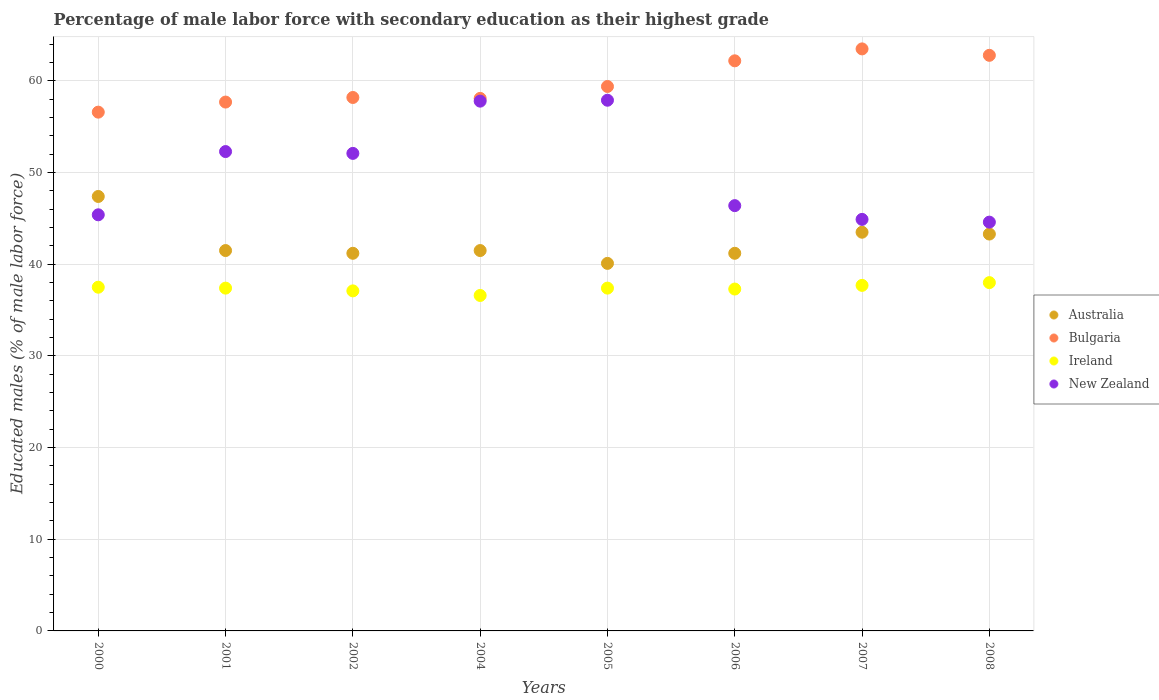Is the number of dotlines equal to the number of legend labels?
Your answer should be very brief. Yes. What is the percentage of male labor force with secondary education in New Zealand in 2006?
Your answer should be compact. 46.4. Across all years, what is the maximum percentage of male labor force with secondary education in New Zealand?
Offer a terse response. 57.9. Across all years, what is the minimum percentage of male labor force with secondary education in Bulgaria?
Offer a very short reply. 56.6. What is the total percentage of male labor force with secondary education in New Zealand in the graph?
Offer a very short reply. 401.4. What is the difference between the percentage of male labor force with secondary education in Ireland in 2002 and that in 2006?
Your response must be concise. -0.2. What is the average percentage of male labor force with secondary education in Australia per year?
Keep it short and to the point. 42.46. In the year 2007, what is the difference between the percentage of male labor force with secondary education in Bulgaria and percentage of male labor force with secondary education in New Zealand?
Make the answer very short. 18.6. In how many years, is the percentage of male labor force with secondary education in Ireland greater than 50 %?
Provide a short and direct response. 0. What is the ratio of the percentage of male labor force with secondary education in Australia in 2006 to that in 2007?
Offer a very short reply. 0.95. Is the percentage of male labor force with secondary education in Bulgaria in 2000 less than that in 2007?
Offer a terse response. Yes. What is the difference between the highest and the second highest percentage of male labor force with secondary education in New Zealand?
Provide a succinct answer. 0.1. What is the difference between the highest and the lowest percentage of male labor force with secondary education in Bulgaria?
Your answer should be very brief. 6.9. In how many years, is the percentage of male labor force with secondary education in New Zealand greater than the average percentage of male labor force with secondary education in New Zealand taken over all years?
Your answer should be very brief. 4. Does the percentage of male labor force with secondary education in Australia monotonically increase over the years?
Offer a terse response. No. Is the percentage of male labor force with secondary education in Ireland strictly less than the percentage of male labor force with secondary education in Bulgaria over the years?
Keep it short and to the point. Yes. How many dotlines are there?
Your response must be concise. 4. How many years are there in the graph?
Provide a succinct answer. 8. What is the difference between two consecutive major ticks on the Y-axis?
Provide a short and direct response. 10. Does the graph contain any zero values?
Your answer should be very brief. No. Where does the legend appear in the graph?
Give a very brief answer. Center right. How many legend labels are there?
Provide a short and direct response. 4. How are the legend labels stacked?
Provide a succinct answer. Vertical. What is the title of the graph?
Ensure brevity in your answer.  Percentage of male labor force with secondary education as their highest grade. Does "Angola" appear as one of the legend labels in the graph?
Your answer should be very brief. No. What is the label or title of the X-axis?
Provide a short and direct response. Years. What is the label or title of the Y-axis?
Offer a very short reply. Educated males (% of male labor force). What is the Educated males (% of male labor force) in Australia in 2000?
Offer a terse response. 47.4. What is the Educated males (% of male labor force) of Bulgaria in 2000?
Offer a very short reply. 56.6. What is the Educated males (% of male labor force) of Ireland in 2000?
Ensure brevity in your answer.  37.5. What is the Educated males (% of male labor force) in New Zealand in 2000?
Make the answer very short. 45.4. What is the Educated males (% of male labor force) in Australia in 2001?
Ensure brevity in your answer.  41.5. What is the Educated males (% of male labor force) in Bulgaria in 2001?
Your answer should be very brief. 57.7. What is the Educated males (% of male labor force) of Ireland in 2001?
Give a very brief answer. 37.4. What is the Educated males (% of male labor force) in New Zealand in 2001?
Ensure brevity in your answer.  52.3. What is the Educated males (% of male labor force) in Australia in 2002?
Make the answer very short. 41.2. What is the Educated males (% of male labor force) in Bulgaria in 2002?
Keep it short and to the point. 58.2. What is the Educated males (% of male labor force) in Ireland in 2002?
Your response must be concise. 37.1. What is the Educated males (% of male labor force) in New Zealand in 2002?
Ensure brevity in your answer.  52.1. What is the Educated males (% of male labor force) of Australia in 2004?
Your answer should be compact. 41.5. What is the Educated males (% of male labor force) in Bulgaria in 2004?
Offer a very short reply. 58.1. What is the Educated males (% of male labor force) in Ireland in 2004?
Provide a short and direct response. 36.6. What is the Educated males (% of male labor force) in New Zealand in 2004?
Your response must be concise. 57.8. What is the Educated males (% of male labor force) in Australia in 2005?
Provide a short and direct response. 40.1. What is the Educated males (% of male labor force) of Bulgaria in 2005?
Your answer should be very brief. 59.4. What is the Educated males (% of male labor force) of Ireland in 2005?
Ensure brevity in your answer.  37.4. What is the Educated males (% of male labor force) of New Zealand in 2005?
Your response must be concise. 57.9. What is the Educated males (% of male labor force) of Australia in 2006?
Your answer should be very brief. 41.2. What is the Educated males (% of male labor force) of Bulgaria in 2006?
Provide a short and direct response. 62.2. What is the Educated males (% of male labor force) of Ireland in 2006?
Make the answer very short. 37.3. What is the Educated males (% of male labor force) of New Zealand in 2006?
Provide a succinct answer. 46.4. What is the Educated males (% of male labor force) in Australia in 2007?
Your answer should be compact. 43.5. What is the Educated males (% of male labor force) of Bulgaria in 2007?
Your response must be concise. 63.5. What is the Educated males (% of male labor force) in Ireland in 2007?
Provide a succinct answer. 37.7. What is the Educated males (% of male labor force) of New Zealand in 2007?
Keep it short and to the point. 44.9. What is the Educated males (% of male labor force) in Australia in 2008?
Your response must be concise. 43.3. What is the Educated males (% of male labor force) in Bulgaria in 2008?
Give a very brief answer. 62.8. What is the Educated males (% of male labor force) in New Zealand in 2008?
Your response must be concise. 44.6. Across all years, what is the maximum Educated males (% of male labor force) in Australia?
Keep it short and to the point. 47.4. Across all years, what is the maximum Educated males (% of male labor force) in Bulgaria?
Offer a terse response. 63.5. Across all years, what is the maximum Educated males (% of male labor force) in New Zealand?
Make the answer very short. 57.9. Across all years, what is the minimum Educated males (% of male labor force) in Australia?
Make the answer very short. 40.1. Across all years, what is the minimum Educated males (% of male labor force) in Bulgaria?
Make the answer very short. 56.6. Across all years, what is the minimum Educated males (% of male labor force) of Ireland?
Your answer should be compact. 36.6. Across all years, what is the minimum Educated males (% of male labor force) of New Zealand?
Provide a short and direct response. 44.6. What is the total Educated males (% of male labor force) in Australia in the graph?
Provide a succinct answer. 339.7. What is the total Educated males (% of male labor force) in Bulgaria in the graph?
Give a very brief answer. 478.5. What is the total Educated males (% of male labor force) of Ireland in the graph?
Offer a very short reply. 299. What is the total Educated males (% of male labor force) of New Zealand in the graph?
Make the answer very short. 401.4. What is the difference between the Educated males (% of male labor force) of Ireland in 2000 and that in 2002?
Provide a short and direct response. 0.4. What is the difference between the Educated males (% of male labor force) in Australia in 2000 and that in 2004?
Provide a short and direct response. 5.9. What is the difference between the Educated males (% of male labor force) of Bulgaria in 2000 and that in 2004?
Keep it short and to the point. -1.5. What is the difference between the Educated males (% of male labor force) in Ireland in 2000 and that in 2004?
Your response must be concise. 0.9. What is the difference between the Educated males (% of male labor force) of New Zealand in 2000 and that in 2004?
Your answer should be compact. -12.4. What is the difference between the Educated males (% of male labor force) of Australia in 2000 and that in 2005?
Offer a terse response. 7.3. What is the difference between the Educated males (% of male labor force) in Ireland in 2000 and that in 2005?
Keep it short and to the point. 0.1. What is the difference between the Educated males (% of male labor force) of New Zealand in 2000 and that in 2005?
Offer a very short reply. -12.5. What is the difference between the Educated males (% of male labor force) of Australia in 2000 and that in 2006?
Provide a short and direct response. 6.2. What is the difference between the Educated males (% of male labor force) of Bulgaria in 2000 and that in 2006?
Your answer should be very brief. -5.6. What is the difference between the Educated males (% of male labor force) of New Zealand in 2000 and that in 2006?
Your response must be concise. -1. What is the difference between the Educated males (% of male labor force) in Australia in 2000 and that in 2008?
Offer a very short reply. 4.1. What is the difference between the Educated males (% of male labor force) in Bulgaria in 2000 and that in 2008?
Provide a succinct answer. -6.2. What is the difference between the Educated males (% of male labor force) of New Zealand in 2000 and that in 2008?
Give a very brief answer. 0.8. What is the difference between the Educated males (% of male labor force) in Bulgaria in 2001 and that in 2002?
Offer a very short reply. -0.5. What is the difference between the Educated males (% of male labor force) in Australia in 2001 and that in 2004?
Ensure brevity in your answer.  0. What is the difference between the Educated males (% of male labor force) in Australia in 2001 and that in 2005?
Keep it short and to the point. 1.4. What is the difference between the Educated males (% of male labor force) of Bulgaria in 2001 and that in 2005?
Your answer should be compact. -1.7. What is the difference between the Educated males (% of male labor force) of Ireland in 2001 and that in 2005?
Offer a very short reply. 0. What is the difference between the Educated males (% of male labor force) in New Zealand in 2001 and that in 2005?
Offer a very short reply. -5.6. What is the difference between the Educated males (% of male labor force) in Australia in 2001 and that in 2006?
Keep it short and to the point. 0.3. What is the difference between the Educated males (% of male labor force) in Bulgaria in 2001 and that in 2006?
Provide a short and direct response. -4.5. What is the difference between the Educated males (% of male labor force) of Ireland in 2001 and that in 2008?
Your answer should be compact. -0.6. What is the difference between the Educated males (% of male labor force) in Ireland in 2002 and that in 2004?
Make the answer very short. 0.5. What is the difference between the Educated males (% of male labor force) in Australia in 2002 and that in 2005?
Your answer should be compact. 1.1. What is the difference between the Educated males (% of male labor force) in Ireland in 2002 and that in 2005?
Keep it short and to the point. -0.3. What is the difference between the Educated males (% of male labor force) in New Zealand in 2002 and that in 2005?
Offer a very short reply. -5.8. What is the difference between the Educated males (% of male labor force) in Australia in 2002 and that in 2006?
Make the answer very short. 0. What is the difference between the Educated males (% of male labor force) in Bulgaria in 2002 and that in 2006?
Offer a very short reply. -4. What is the difference between the Educated males (% of male labor force) in Australia in 2002 and that in 2007?
Make the answer very short. -2.3. What is the difference between the Educated males (% of male labor force) of Bulgaria in 2002 and that in 2007?
Your answer should be compact. -5.3. What is the difference between the Educated males (% of male labor force) in Ireland in 2002 and that in 2007?
Your answer should be very brief. -0.6. What is the difference between the Educated males (% of male labor force) of New Zealand in 2002 and that in 2007?
Your answer should be very brief. 7.2. What is the difference between the Educated males (% of male labor force) of Australia in 2002 and that in 2008?
Make the answer very short. -2.1. What is the difference between the Educated males (% of male labor force) of Ireland in 2002 and that in 2008?
Offer a very short reply. -0.9. What is the difference between the Educated males (% of male labor force) of Australia in 2004 and that in 2005?
Make the answer very short. 1.4. What is the difference between the Educated males (% of male labor force) of Bulgaria in 2004 and that in 2005?
Provide a succinct answer. -1.3. What is the difference between the Educated males (% of male labor force) in Ireland in 2004 and that in 2005?
Ensure brevity in your answer.  -0.8. What is the difference between the Educated males (% of male labor force) in Bulgaria in 2004 and that in 2006?
Offer a very short reply. -4.1. What is the difference between the Educated males (% of male labor force) in New Zealand in 2004 and that in 2006?
Offer a terse response. 11.4. What is the difference between the Educated males (% of male labor force) in Ireland in 2004 and that in 2007?
Offer a very short reply. -1.1. What is the difference between the Educated males (% of male labor force) of New Zealand in 2004 and that in 2007?
Offer a very short reply. 12.9. What is the difference between the Educated males (% of male labor force) in Bulgaria in 2004 and that in 2008?
Ensure brevity in your answer.  -4.7. What is the difference between the Educated males (% of male labor force) of New Zealand in 2004 and that in 2008?
Give a very brief answer. 13.2. What is the difference between the Educated males (% of male labor force) of Ireland in 2005 and that in 2006?
Give a very brief answer. 0.1. What is the difference between the Educated males (% of male labor force) in New Zealand in 2005 and that in 2007?
Provide a succinct answer. 13. What is the difference between the Educated males (% of male labor force) of New Zealand in 2005 and that in 2008?
Provide a short and direct response. 13.3. What is the difference between the Educated males (% of male labor force) of Ireland in 2006 and that in 2007?
Ensure brevity in your answer.  -0.4. What is the difference between the Educated males (% of male labor force) in New Zealand in 2006 and that in 2007?
Provide a short and direct response. 1.5. What is the difference between the Educated males (% of male labor force) in Australia in 2007 and that in 2008?
Give a very brief answer. 0.2. What is the difference between the Educated males (% of male labor force) in Bulgaria in 2007 and that in 2008?
Offer a very short reply. 0.7. What is the difference between the Educated males (% of male labor force) of Ireland in 2007 and that in 2008?
Ensure brevity in your answer.  -0.3. What is the difference between the Educated males (% of male labor force) of New Zealand in 2007 and that in 2008?
Provide a succinct answer. 0.3. What is the difference between the Educated males (% of male labor force) of Bulgaria in 2000 and the Educated males (% of male labor force) of Ireland in 2001?
Your answer should be very brief. 19.2. What is the difference between the Educated males (% of male labor force) of Ireland in 2000 and the Educated males (% of male labor force) of New Zealand in 2001?
Your answer should be compact. -14.8. What is the difference between the Educated males (% of male labor force) of Australia in 2000 and the Educated males (% of male labor force) of Bulgaria in 2002?
Ensure brevity in your answer.  -10.8. What is the difference between the Educated males (% of male labor force) in Bulgaria in 2000 and the Educated males (% of male labor force) in Ireland in 2002?
Your response must be concise. 19.5. What is the difference between the Educated males (% of male labor force) in Bulgaria in 2000 and the Educated males (% of male labor force) in New Zealand in 2002?
Your answer should be compact. 4.5. What is the difference between the Educated males (% of male labor force) of Ireland in 2000 and the Educated males (% of male labor force) of New Zealand in 2002?
Offer a terse response. -14.6. What is the difference between the Educated males (% of male labor force) in Australia in 2000 and the Educated males (% of male labor force) in Ireland in 2004?
Make the answer very short. 10.8. What is the difference between the Educated males (% of male labor force) in Australia in 2000 and the Educated males (% of male labor force) in New Zealand in 2004?
Your answer should be very brief. -10.4. What is the difference between the Educated males (% of male labor force) of Bulgaria in 2000 and the Educated males (% of male labor force) of New Zealand in 2004?
Provide a short and direct response. -1.2. What is the difference between the Educated males (% of male labor force) in Ireland in 2000 and the Educated males (% of male labor force) in New Zealand in 2004?
Give a very brief answer. -20.3. What is the difference between the Educated males (% of male labor force) of Australia in 2000 and the Educated males (% of male labor force) of Bulgaria in 2005?
Your response must be concise. -12. What is the difference between the Educated males (% of male labor force) in Bulgaria in 2000 and the Educated males (% of male labor force) in Ireland in 2005?
Your answer should be compact. 19.2. What is the difference between the Educated males (% of male labor force) of Bulgaria in 2000 and the Educated males (% of male labor force) of New Zealand in 2005?
Keep it short and to the point. -1.3. What is the difference between the Educated males (% of male labor force) in Ireland in 2000 and the Educated males (% of male labor force) in New Zealand in 2005?
Ensure brevity in your answer.  -20.4. What is the difference between the Educated males (% of male labor force) in Australia in 2000 and the Educated males (% of male labor force) in Bulgaria in 2006?
Your answer should be compact. -14.8. What is the difference between the Educated males (% of male labor force) of Australia in 2000 and the Educated males (% of male labor force) of Ireland in 2006?
Your response must be concise. 10.1. What is the difference between the Educated males (% of male labor force) of Bulgaria in 2000 and the Educated males (% of male labor force) of Ireland in 2006?
Offer a terse response. 19.3. What is the difference between the Educated males (% of male labor force) in Australia in 2000 and the Educated males (% of male labor force) in Bulgaria in 2007?
Offer a terse response. -16.1. What is the difference between the Educated males (% of male labor force) of Australia in 2000 and the Educated males (% of male labor force) of Ireland in 2007?
Provide a succinct answer. 9.7. What is the difference between the Educated males (% of male labor force) of Australia in 2000 and the Educated males (% of male labor force) of New Zealand in 2007?
Your answer should be compact. 2.5. What is the difference between the Educated males (% of male labor force) of Bulgaria in 2000 and the Educated males (% of male labor force) of Ireland in 2007?
Your answer should be compact. 18.9. What is the difference between the Educated males (% of male labor force) in Ireland in 2000 and the Educated males (% of male labor force) in New Zealand in 2007?
Offer a terse response. -7.4. What is the difference between the Educated males (% of male labor force) in Australia in 2000 and the Educated males (% of male labor force) in Bulgaria in 2008?
Offer a very short reply. -15.4. What is the difference between the Educated males (% of male labor force) in Australia in 2000 and the Educated males (% of male labor force) in Ireland in 2008?
Your answer should be compact. 9.4. What is the difference between the Educated males (% of male labor force) in Australia in 2000 and the Educated males (% of male labor force) in New Zealand in 2008?
Provide a short and direct response. 2.8. What is the difference between the Educated males (% of male labor force) in Bulgaria in 2000 and the Educated males (% of male labor force) in New Zealand in 2008?
Ensure brevity in your answer.  12. What is the difference between the Educated males (% of male labor force) in Ireland in 2000 and the Educated males (% of male labor force) in New Zealand in 2008?
Make the answer very short. -7.1. What is the difference between the Educated males (% of male labor force) in Australia in 2001 and the Educated males (% of male labor force) in Bulgaria in 2002?
Provide a short and direct response. -16.7. What is the difference between the Educated males (% of male labor force) in Australia in 2001 and the Educated males (% of male labor force) in Ireland in 2002?
Offer a very short reply. 4.4. What is the difference between the Educated males (% of male labor force) of Australia in 2001 and the Educated males (% of male labor force) of New Zealand in 2002?
Your answer should be compact. -10.6. What is the difference between the Educated males (% of male labor force) of Bulgaria in 2001 and the Educated males (% of male labor force) of Ireland in 2002?
Provide a short and direct response. 20.6. What is the difference between the Educated males (% of male labor force) in Bulgaria in 2001 and the Educated males (% of male labor force) in New Zealand in 2002?
Your answer should be compact. 5.6. What is the difference between the Educated males (% of male labor force) in Ireland in 2001 and the Educated males (% of male labor force) in New Zealand in 2002?
Your answer should be very brief. -14.7. What is the difference between the Educated males (% of male labor force) in Australia in 2001 and the Educated males (% of male labor force) in Bulgaria in 2004?
Provide a short and direct response. -16.6. What is the difference between the Educated males (% of male labor force) of Australia in 2001 and the Educated males (% of male labor force) of Ireland in 2004?
Ensure brevity in your answer.  4.9. What is the difference between the Educated males (% of male labor force) in Australia in 2001 and the Educated males (% of male labor force) in New Zealand in 2004?
Give a very brief answer. -16.3. What is the difference between the Educated males (% of male labor force) in Bulgaria in 2001 and the Educated males (% of male labor force) in Ireland in 2004?
Provide a short and direct response. 21.1. What is the difference between the Educated males (% of male labor force) in Ireland in 2001 and the Educated males (% of male labor force) in New Zealand in 2004?
Provide a succinct answer. -20.4. What is the difference between the Educated males (% of male labor force) in Australia in 2001 and the Educated males (% of male labor force) in Bulgaria in 2005?
Your answer should be very brief. -17.9. What is the difference between the Educated males (% of male labor force) of Australia in 2001 and the Educated males (% of male labor force) of Ireland in 2005?
Your response must be concise. 4.1. What is the difference between the Educated males (% of male labor force) in Australia in 2001 and the Educated males (% of male labor force) in New Zealand in 2005?
Your response must be concise. -16.4. What is the difference between the Educated males (% of male labor force) of Bulgaria in 2001 and the Educated males (% of male labor force) of Ireland in 2005?
Provide a succinct answer. 20.3. What is the difference between the Educated males (% of male labor force) in Ireland in 2001 and the Educated males (% of male labor force) in New Zealand in 2005?
Your answer should be compact. -20.5. What is the difference between the Educated males (% of male labor force) in Australia in 2001 and the Educated males (% of male labor force) in Bulgaria in 2006?
Provide a succinct answer. -20.7. What is the difference between the Educated males (% of male labor force) of Australia in 2001 and the Educated males (% of male labor force) of New Zealand in 2006?
Offer a very short reply. -4.9. What is the difference between the Educated males (% of male labor force) in Bulgaria in 2001 and the Educated males (% of male labor force) in Ireland in 2006?
Keep it short and to the point. 20.4. What is the difference between the Educated males (% of male labor force) of Ireland in 2001 and the Educated males (% of male labor force) of New Zealand in 2006?
Your answer should be compact. -9. What is the difference between the Educated males (% of male labor force) in Australia in 2001 and the Educated males (% of male labor force) in Bulgaria in 2007?
Keep it short and to the point. -22. What is the difference between the Educated males (% of male labor force) in Australia in 2001 and the Educated males (% of male labor force) in New Zealand in 2007?
Offer a very short reply. -3.4. What is the difference between the Educated males (% of male labor force) in Bulgaria in 2001 and the Educated males (% of male labor force) in New Zealand in 2007?
Give a very brief answer. 12.8. What is the difference between the Educated males (% of male labor force) of Ireland in 2001 and the Educated males (% of male labor force) of New Zealand in 2007?
Provide a short and direct response. -7.5. What is the difference between the Educated males (% of male labor force) of Australia in 2001 and the Educated males (% of male labor force) of Bulgaria in 2008?
Your answer should be compact. -21.3. What is the difference between the Educated males (% of male labor force) of Australia in 2001 and the Educated males (% of male labor force) of Ireland in 2008?
Give a very brief answer. 3.5. What is the difference between the Educated males (% of male labor force) in Bulgaria in 2001 and the Educated males (% of male labor force) in New Zealand in 2008?
Offer a terse response. 13.1. What is the difference between the Educated males (% of male labor force) of Australia in 2002 and the Educated males (% of male labor force) of Bulgaria in 2004?
Make the answer very short. -16.9. What is the difference between the Educated males (% of male labor force) of Australia in 2002 and the Educated males (% of male labor force) of New Zealand in 2004?
Provide a succinct answer. -16.6. What is the difference between the Educated males (% of male labor force) in Bulgaria in 2002 and the Educated males (% of male labor force) in Ireland in 2004?
Provide a succinct answer. 21.6. What is the difference between the Educated males (% of male labor force) of Ireland in 2002 and the Educated males (% of male labor force) of New Zealand in 2004?
Provide a short and direct response. -20.7. What is the difference between the Educated males (% of male labor force) of Australia in 2002 and the Educated males (% of male labor force) of Bulgaria in 2005?
Make the answer very short. -18.2. What is the difference between the Educated males (% of male labor force) of Australia in 2002 and the Educated males (% of male labor force) of New Zealand in 2005?
Offer a very short reply. -16.7. What is the difference between the Educated males (% of male labor force) in Bulgaria in 2002 and the Educated males (% of male labor force) in Ireland in 2005?
Offer a terse response. 20.8. What is the difference between the Educated males (% of male labor force) of Bulgaria in 2002 and the Educated males (% of male labor force) of New Zealand in 2005?
Give a very brief answer. 0.3. What is the difference between the Educated males (% of male labor force) of Ireland in 2002 and the Educated males (% of male labor force) of New Zealand in 2005?
Offer a very short reply. -20.8. What is the difference between the Educated males (% of male labor force) of Australia in 2002 and the Educated males (% of male labor force) of Bulgaria in 2006?
Your response must be concise. -21. What is the difference between the Educated males (% of male labor force) in Bulgaria in 2002 and the Educated males (% of male labor force) in Ireland in 2006?
Offer a very short reply. 20.9. What is the difference between the Educated males (% of male labor force) of Ireland in 2002 and the Educated males (% of male labor force) of New Zealand in 2006?
Keep it short and to the point. -9.3. What is the difference between the Educated males (% of male labor force) in Australia in 2002 and the Educated males (% of male labor force) in Bulgaria in 2007?
Make the answer very short. -22.3. What is the difference between the Educated males (% of male labor force) of Australia in 2002 and the Educated males (% of male labor force) of Bulgaria in 2008?
Give a very brief answer. -21.6. What is the difference between the Educated males (% of male labor force) of Australia in 2002 and the Educated males (% of male labor force) of Ireland in 2008?
Provide a short and direct response. 3.2. What is the difference between the Educated males (% of male labor force) of Bulgaria in 2002 and the Educated males (% of male labor force) of Ireland in 2008?
Your answer should be compact. 20.2. What is the difference between the Educated males (% of male labor force) of Bulgaria in 2002 and the Educated males (% of male labor force) of New Zealand in 2008?
Offer a very short reply. 13.6. What is the difference between the Educated males (% of male labor force) of Australia in 2004 and the Educated males (% of male labor force) of Bulgaria in 2005?
Your answer should be compact. -17.9. What is the difference between the Educated males (% of male labor force) in Australia in 2004 and the Educated males (% of male labor force) in New Zealand in 2005?
Your response must be concise. -16.4. What is the difference between the Educated males (% of male labor force) of Bulgaria in 2004 and the Educated males (% of male labor force) of Ireland in 2005?
Keep it short and to the point. 20.7. What is the difference between the Educated males (% of male labor force) of Ireland in 2004 and the Educated males (% of male labor force) of New Zealand in 2005?
Offer a terse response. -21.3. What is the difference between the Educated males (% of male labor force) of Australia in 2004 and the Educated males (% of male labor force) of Bulgaria in 2006?
Your response must be concise. -20.7. What is the difference between the Educated males (% of male labor force) of Australia in 2004 and the Educated males (% of male labor force) of New Zealand in 2006?
Your answer should be very brief. -4.9. What is the difference between the Educated males (% of male labor force) in Bulgaria in 2004 and the Educated males (% of male labor force) in Ireland in 2006?
Your answer should be compact. 20.8. What is the difference between the Educated males (% of male labor force) of Ireland in 2004 and the Educated males (% of male labor force) of New Zealand in 2006?
Ensure brevity in your answer.  -9.8. What is the difference between the Educated males (% of male labor force) in Australia in 2004 and the Educated males (% of male labor force) in Bulgaria in 2007?
Provide a short and direct response. -22. What is the difference between the Educated males (% of male labor force) of Australia in 2004 and the Educated males (% of male labor force) of Ireland in 2007?
Make the answer very short. 3.8. What is the difference between the Educated males (% of male labor force) in Australia in 2004 and the Educated males (% of male labor force) in New Zealand in 2007?
Your answer should be compact. -3.4. What is the difference between the Educated males (% of male labor force) of Bulgaria in 2004 and the Educated males (% of male labor force) of Ireland in 2007?
Provide a succinct answer. 20.4. What is the difference between the Educated males (% of male labor force) of Ireland in 2004 and the Educated males (% of male labor force) of New Zealand in 2007?
Give a very brief answer. -8.3. What is the difference between the Educated males (% of male labor force) in Australia in 2004 and the Educated males (% of male labor force) in Bulgaria in 2008?
Your answer should be very brief. -21.3. What is the difference between the Educated males (% of male labor force) in Bulgaria in 2004 and the Educated males (% of male labor force) in Ireland in 2008?
Keep it short and to the point. 20.1. What is the difference between the Educated males (% of male labor force) of Australia in 2005 and the Educated males (% of male labor force) of Bulgaria in 2006?
Make the answer very short. -22.1. What is the difference between the Educated males (% of male labor force) in Australia in 2005 and the Educated males (% of male labor force) in Ireland in 2006?
Make the answer very short. 2.8. What is the difference between the Educated males (% of male labor force) in Australia in 2005 and the Educated males (% of male labor force) in New Zealand in 2006?
Your answer should be compact. -6.3. What is the difference between the Educated males (% of male labor force) of Bulgaria in 2005 and the Educated males (% of male labor force) of Ireland in 2006?
Your response must be concise. 22.1. What is the difference between the Educated males (% of male labor force) of Australia in 2005 and the Educated males (% of male labor force) of Bulgaria in 2007?
Offer a very short reply. -23.4. What is the difference between the Educated males (% of male labor force) in Australia in 2005 and the Educated males (% of male labor force) in Ireland in 2007?
Offer a very short reply. 2.4. What is the difference between the Educated males (% of male labor force) of Australia in 2005 and the Educated males (% of male labor force) of New Zealand in 2007?
Your response must be concise. -4.8. What is the difference between the Educated males (% of male labor force) of Bulgaria in 2005 and the Educated males (% of male labor force) of Ireland in 2007?
Ensure brevity in your answer.  21.7. What is the difference between the Educated males (% of male labor force) in Bulgaria in 2005 and the Educated males (% of male labor force) in New Zealand in 2007?
Your answer should be very brief. 14.5. What is the difference between the Educated males (% of male labor force) of Australia in 2005 and the Educated males (% of male labor force) of Bulgaria in 2008?
Provide a short and direct response. -22.7. What is the difference between the Educated males (% of male labor force) in Bulgaria in 2005 and the Educated males (% of male labor force) in Ireland in 2008?
Give a very brief answer. 21.4. What is the difference between the Educated males (% of male labor force) in Ireland in 2005 and the Educated males (% of male labor force) in New Zealand in 2008?
Your answer should be very brief. -7.2. What is the difference between the Educated males (% of male labor force) of Australia in 2006 and the Educated males (% of male labor force) of Bulgaria in 2007?
Your response must be concise. -22.3. What is the difference between the Educated males (% of male labor force) of Australia in 2006 and the Educated males (% of male labor force) of Ireland in 2007?
Your answer should be compact. 3.5. What is the difference between the Educated males (% of male labor force) of Australia in 2006 and the Educated males (% of male labor force) of New Zealand in 2007?
Your response must be concise. -3.7. What is the difference between the Educated males (% of male labor force) in Bulgaria in 2006 and the Educated males (% of male labor force) in Ireland in 2007?
Keep it short and to the point. 24.5. What is the difference between the Educated males (% of male labor force) in Bulgaria in 2006 and the Educated males (% of male labor force) in New Zealand in 2007?
Your answer should be compact. 17.3. What is the difference between the Educated males (% of male labor force) of Australia in 2006 and the Educated males (% of male labor force) of Bulgaria in 2008?
Ensure brevity in your answer.  -21.6. What is the difference between the Educated males (% of male labor force) in Australia in 2006 and the Educated males (% of male labor force) in Ireland in 2008?
Keep it short and to the point. 3.2. What is the difference between the Educated males (% of male labor force) of Australia in 2006 and the Educated males (% of male labor force) of New Zealand in 2008?
Provide a short and direct response. -3.4. What is the difference between the Educated males (% of male labor force) in Bulgaria in 2006 and the Educated males (% of male labor force) in Ireland in 2008?
Keep it short and to the point. 24.2. What is the difference between the Educated males (% of male labor force) in Australia in 2007 and the Educated males (% of male labor force) in Bulgaria in 2008?
Provide a short and direct response. -19.3. What is the difference between the Educated males (% of male labor force) of Australia in 2007 and the Educated males (% of male labor force) of Ireland in 2008?
Provide a succinct answer. 5.5. What is the difference between the Educated males (% of male labor force) of Bulgaria in 2007 and the Educated males (% of male labor force) of Ireland in 2008?
Provide a succinct answer. 25.5. What is the difference between the Educated males (% of male labor force) in Bulgaria in 2007 and the Educated males (% of male labor force) in New Zealand in 2008?
Your response must be concise. 18.9. What is the difference between the Educated males (% of male labor force) of Ireland in 2007 and the Educated males (% of male labor force) of New Zealand in 2008?
Ensure brevity in your answer.  -6.9. What is the average Educated males (% of male labor force) in Australia per year?
Provide a short and direct response. 42.46. What is the average Educated males (% of male labor force) of Bulgaria per year?
Keep it short and to the point. 59.81. What is the average Educated males (% of male labor force) in Ireland per year?
Keep it short and to the point. 37.38. What is the average Educated males (% of male labor force) in New Zealand per year?
Offer a terse response. 50.17. In the year 2000, what is the difference between the Educated males (% of male labor force) in Australia and Educated males (% of male labor force) in Bulgaria?
Keep it short and to the point. -9.2. In the year 2000, what is the difference between the Educated males (% of male labor force) in Australia and Educated males (% of male labor force) in Ireland?
Your response must be concise. 9.9. In the year 2000, what is the difference between the Educated males (% of male labor force) in Australia and Educated males (% of male labor force) in New Zealand?
Offer a terse response. 2. In the year 2000, what is the difference between the Educated males (% of male labor force) of Bulgaria and Educated males (% of male labor force) of Ireland?
Your response must be concise. 19.1. In the year 2000, what is the difference between the Educated males (% of male labor force) of Bulgaria and Educated males (% of male labor force) of New Zealand?
Offer a terse response. 11.2. In the year 2001, what is the difference between the Educated males (% of male labor force) in Australia and Educated males (% of male labor force) in Bulgaria?
Your response must be concise. -16.2. In the year 2001, what is the difference between the Educated males (% of male labor force) of Bulgaria and Educated males (% of male labor force) of Ireland?
Give a very brief answer. 20.3. In the year 2001, what is the difference between the Educated males (% of male labor force) in Bulgaria and Educated males (% of male labor force) in New Zealand?
Provide a short and direct response. 5.4. In the year 2001, what is the difference between the Educated males (% of male labor force) in Ireland and Educated males (% of male labor force) in New Zealand?
Offer a very short reply. -14.9. In the year 2002, what is the difference between the Educated males (% of male labor force) of Australia and Educated males (% of male labor force) of Ireland?
Ensure brevity in your answer.  4.1. In the year 2002, what is the difference between the Educated males (% of male labor force) in Bulgaria and Educated males (% of male labor force) in Ireland?
Provide a short and direct response. 21.1. In the year 2002, what is the difference between the Educated males (% of male labor force) of Bulgaria and Educated males (% of male labor force) of New Zealand?
Ensure brevity in your answer.  6.1. In the year 2002, what is the difference between the Educated males (% of male labor force) in Ireland and Educated males (% of male labor force) in New Zealand?
Offer a very short reply. -15. In the year 2004, what is the difference between the Educated males (% of male labor force) of Australia and Educated males (% of male labor force) of Bulgaria?
Provide a succinct answer. -16.6. In the year 2004, what is the difference between the Educated males (% of male labor force) of Australia and Educated males (% of male labor force) of Ireland?
Provide a short and direct response. 4.9. In the year 2004, what is the difference between the Educated males (% of male labor force) of Australia and Educated males (% of male labor force) of New Zealand?
Your answer should be very brief. -16.3. In the year 2004, what is the difference between the Educated males (% of male labor force) in Bulgaria and Educated males (% of male labor force) in Ireland?
Keep it short and to the point. 21.5. In the year 2004, what is the difference between the Educated males (% of male labor force) of Ireland and Educated males (% of male labor force) of New Zealand?
Make the answer very short. -21.2. In the year 2005, what is the difference between the Educated males (% of male labor force) of Australia and Educated males (% of male labor force) of Bulgaria?
Offer a very short reply. -19.3. In the year 2005, what is the difference between the Educated males (% of male labor force) of Australia and Educated males (% of male labor force) of Ireland?
Provide a succinct answer. 2.7. In the year 2005, what is the difference between the Educated males (% of male labor force) in Australia and Educated males (% of male labor force) in New Zealand?
Your response must be concise. -17.8. In the year 2005, what is the difference between the Educated males (% of male labor force) of Ireland and Educated males (% of male labor force) of New Zealand?
Your response must be concise. -20.5. In the year 2006, what is the difference between the Educated males (% of male labor force) in Bulgaria and Educated males (% of male labor force) in Ireland?
Your answer should be very brief. 24.9. In the year 2006, what is the difference between the Educated males (% of male labor force) in Bulgaria and Educated males (% of male labor force) in New Zealand?
Your answer should be very brief. 15.8. In the year 2006, what is the difference between the Educated males (% of male labor force) of Ireland and Educated males (% of male labor force) of New Zealand?
Offer a very short reply. -9.1. In the year 2007, what is the difference between the Educated males (% of male labor force) of Australia and Educated males (% of male labor force) of Ireland?
Make the answer very short. 5.8. In the year 2007, what is the difference between the Educated males (% of male labor force) in Australia and Educated males (% of male labor force) in New Zealand?
Your answer should be compact. -1.4. In the year 2007, what is the difference between the Educated males (% of male labor force) of Bulgaria and Educated males (% of male labor force) of Ireland?
Give a very brief answer. 25.8. In the year 2007, what is the difference between the Educated males (% of male labor force) of Bulgaria and Educated males (% of male labor force) of New Zealand?
Ensure brevity in your answer.  18.6. In the year 2007, what is the difference between the Educated males (% of male labor force) of Ireland and Educated males (% of male labor force) of New Zealand?
Offer a very short reply. -7.2. In the year 2008, what is the difference between the Educated males (% of male labor force) of Australia and Educated males (% of male labor force) of Bulgaria?
Keep it short and to the point. -19.5. In the year 2008, what is the difference between the Educated males (% of male labor force) in Australia and Educated males (% of male labor force) in Ireland?
Your answer should be compact. 5.3. In the year 2008, what is the difference between the Educated males (% of male labor force) in Australia and Educated males (% of male labor force) in New Zealand?
Make the answer very short. -1.3. In the year 2008, what is the difference between the Educated males (% of male labor force) of Bulgaria and Educated males (% of male labor force) of Ireland?
Your answer should be compact. 24.8. In the year 2008, what is the difference between the Educated males (% of male labor force) in Bulgaria and Educated males (% of male labor force) in New Zealand?
Ensure brevity in your answer.  18.2. In the year 2008, what is the difference between the Educated males (% of male labor force) in Ireland and Educated males (% of male labor force) in New Zealand?
Your answer should be compact. -6.6. What is the ratio of the Educated males (% of male labor force) of Australia in 2000 to that in 2001?
Offer a very short reply. 1.14. What is the ratio of the Educated males (% of male labor force) of Bulgaria in 2000 to that in 2001?
Make the answer very short. 0.98. What is the ratio of the Educated males (% of male labor force) of Ireland in 2000 to that in 2001?
Ensure brevity in your answer.  1. What is the ratio of the Educated males (% of male labor force) of New Zealand in 2000 to that in 2001?
Give a very brief answer. 0.87. What is the ratio of the Educated males (% of male labor force) of Australia in 2000 to that in 2002?
Give a very brief answer. 1.15. What is the ratio of the Educated males (% of male labor force) in Bulgaria in 2000 to that in 2002?
Offer a terse response. 0.97. What is the ratio of the Educated males (% of male labor force) of Ireland in 2000 to that in 2002?
Provide a succinct answer. 1.01. What is the ratio of the Educated males (% of male labor force) in New Zealand in 2000 to that in 2002?
Your response must be concise. 0.87. What is the ratio of the Educated males (% of male labor force) in Australia in 2000 to that in 2004?
Ensure brevity in your answer.  1.14. What is the ratio of the Educated males (% of male labor force) of Bulgaria in 2000 to that in 2004?
Provide a succinct answer. 0.97. What is the ratio of the Educated males (% of male labor force) in Ireland in 2000 to that in 2004?
Make the answer very short. 1.02. What is the ratio of the Educated males (% of male labor force) in New Zealand in 2000 to that in 2004?
Your response must be concise. 0.79. What is the ratio of the Educated males (% of male labor force) of Australia in 2000 to that in 2005?
Offer a terse response. 1.18. What is the ratio of the Educated males (% of male labor force) in Bulgaria in 2000 to that in 2005?
Keep it short and to the point. 0.95. What is the ratio of the Educated males (% of male labor force) of New Zealand in 2000 to that in 2005?
Make the answer very short. 0.78. What is the ratio of the Educated males (% of male labor force) of Australia in 2000 to that in 2006?
Keep it short and to the point. 1.15. What is the ratio of the Educated males (% of male labor force) of Bulgaria in 2000 to that in 2006?
Your answer should be very brief. 0.91. What is the ratio of the Educated males (% of male labor force) of Ireland in 2000 to that in 2006?
Give a very brief answer. 1.01. What is the ratio of the Educated males (% of male labor force) of New Zealand in 2000 to that in 2006?
Provide a succinct answer. 0.98. What is the ratio of the Educated males (% of male labor force) in Australia in 2000 to that in 2007?
Ensure brevity in your answer.  1.09. What is the ratio of the Educated males (% of male labor force) of Bulgaria in 2000 to that in 2007?
Your answer should be very brief. 0.89. What is the ratio of the Educated males (% of male labor force) of Ireland in 2000 to that in 2007?
Your answer should be compact. 0.99. What is the ratio of the Educated males (% of male labor force) of New Zealand in 2000 to that in 2007?
Provide a succinct answer. 1.01. What is the ratio of the Educated males (% of male labor force) of Australia in 2000 to that in 2008?
Give a very brief answer. 1.09. What is the ratio of the Educated males (% of male labor force) in Bulgaria in 2000 to that in 2008?
Your answer should be very brief. 0.9. What is the ratio of the Educated males (% of male labor force) of Ireland in 2000 to that in 2008?
Ensure brevity in your answer.  0.99. What is the ratio of the Educated males (% of male labor force) of New Zealand in 2000 to that in 2008?
Offer a very short reply. 1.02. What is the ratio of the Educated males (% of male labor force) of Australia in 2001 to that in 2002?
Your answer should be compact. 1.01. What is the ratio of the Educated males (% of male labor force) in Bulgaria in 2001 to that in 2002?
Keep it short and to the point. 0.99. What is the ratio of the Educated males (% of male labor force) of Ireland in 2001 to that in 2004?
Give a very brief answer. 1.02. What is the ratio of the Educated males (% of male labor force) of New Zealand in 2001 to that in 2004?
Your answer should be very brief. 0.9. What is the ratio of the Educated males (% of male labor force) of Australia in 2001 to that in 2005?
Give a very brief answer. 1.03. What is the ratio of the Educated males (% of male labor force) in Bulgaria in 2001 to that in 2005?
Offer a very short reply. 0.97. What is the ratio of the Educated males (% of male labor force) in Ireland in 2001 to that in 2005?
Ensure brevity in your answer.  1. What is the ratio of the Educated males (% of male labor force) in New Zealand in 2001 to that in 2005?
Provide a succinct answer. 0.9. What is the ratio of the Educated males (% of male labor force) in Australia in 2001 to that in 2006?
Give a very brief answer. 1.01. What is the ratio of the Educated males (% of male labor force) in Bulgaria in 2001 to that in 2006?
Offer a terse response. 0.93. What is the ratio of the Educated males (% of male labor force) in Ireland in 2001 to that in 2006?
Keep it short and to the point. 1. What is the ratio of the Educated males (% of male labor force) in New Zealand in 2001 to that in 2006?
Give a very brief answer. 1.13. What is the ratio of the Educated males (% of male labor force) of Australia in 2001 to that in 2007?
Your answer should be very brief. 0.95. What is the ratio of the Educated males (% of male labor force) of Bulgaria in 2001 to that in 2007?
Provide a succinct answer. 0.91. What is the ratio of the Educated males (% of male labor force) of New Zealand in 2001 to that in 2007?
Your answer should be compact. 1.16. What is the ratio of the Educated males (% of male labor force) of Australia in 2001 to that in 2008?
Your answer should be compact. 0.96. What is the ratio of the Educated males (% of male labor force) of Bulgaria in 2001 to that in 2008?
Make the answer very short. 0.92. What is the ratio of the Educated males (% of male labor force) of Ireland in 2001 to that in 2008?
Your response must be concise. 0.98. What is the ratio of the Educated males (% of male labor force) of New Zealand in 2001 to that in 2008?
Your answer should be compact. 1.17. What is the ratio of the Educated males (% of male labor force) in Australia in 2002 to that in 2004?
Make the answer very short. 0.99. What is the ratio of the Educated males (% of male labor force) in Bulgaria in 2002 to that in 2004?
Offer a very short reply. 1. What is the ratio of the Educated males (% of male labor force) of Ireland in 2002 to that in 2004?
Provide a short and direct response. 1.01. What is the ratio of the Educated males (% of male labor force) in New Zealand in 2002 to that in 2004?
Ensure brevity in your answer.  0.9. What is the ratio of the Educated males (% of male labor force) of Australia in 2002 to that in 2005?
Offer a very short reply. 1.03. What is the ratio of the Educated males (% of male labor force) in Bulgaria in 2002 to that in 2005?
Offer a very short reply. 0.98. What is the ratio of the Educated males (% of male labor force) of New Zealand in 2002 to that in 2005?
Ensure brevity in your answer.  0.9. What is the ratio of the Educated males (% of male labor force) of Australia in 2002 to that in 2006?
Your answer should be compact. 1. What is the ratio of the Educated males (% of male labor force) of Bulgaria in 2002 to that in 2006?
Ensure brevity in your answer.  0.94. What is the ratio of the Educated males (% of male labor force) of Ireland in 2002 to that in 2006?
Give a very brief answer. 0.99. What is the ratio of the Educated males (% of male labor force) in New Zealand in 2002 to that in 2006?
Keep it short and to the point. 1.12. What is the ratio of the Educated males (% of male labor force) in Australia in 2002 to that in 2007?
Keep it short and to the point. 0.95. What is the ratio of the Educated males (% of male labor force) of Bulgaria in 2002 to that in 2007?
Keep it short and to the point. 0.92. What is the ratio of the Educated males (% of male labor force) in Ireland in 2002 to that in 2007?
Give a very brief answer. 0.98. What is the ratio of the Educated males (% of male labor force) in New Zealand in 2002 to that in 2007?
Make the answer very short. 1.16. What is the ratio of the Educated males (% of male labor force) in Australia in 2002 to that in 2008?
Ensure brevity in your answer.  0.95. What is the ratio of the Educated males (% of male labor force) in Bulgaria in 2002 to that in 2008?
Make the answer very short. 0.93. What is the ratio of the Educated males (% of male labor force) of Ireland in 2002 to that in 2008?
Your answer should be very brief. 0.98. What is the ratio of the Educated males (% of male labor force) of New Zealand in 2002 to that in 2008?
Offer a very short reply. 1.17. What is the ratio of the Educated males (% of male labor force) in Australia in 2004 to that in 2005?
Ensure brevity in your answer.  1.03. What is the ratio of the Educated males (% of male labor force) in Bulgaria in 2004 to that in 2005?
Keep it short and to the point. 0.98. What is the ratio of the Educated males (% of male labor force) of Ireland in 2004 to that in 2005?
Your answer should be very brief. 0.98. What is the ratio of the Educated males (% of male labor force) of Australia in 2004 to that in 2006?
Your answer should be compact. 1.01. What is the ratio of the Educated males (% of male labor force) in Bulgaria in 2004 to that in 2006?
Ensure brevity in your answer.  0.93. What is the ratio of the Educated males (% of male labor force) of Ireland in 2004 to that in 2006?
Your answer should be very brief. 0.98. What is the ratio of the Educated males (% of male labor force) in New Zealand in 2004 to that in 2006?
Provide a short and direct response. 1.25. What is the ratio of the Educated males (% of male labor force) of Australia in 2004 to that in 2007?
Offer a very short reply. 0.95. What is the ratio of the Educated males (% of male labor force) in Bulgaria in 2004 to that in 2007?
Offer a terse response. 0.92. What is the ratio of the Educated males (% of male labor force) of Ireland in 2004 to that in 2007?
Your answer should be compact. 0.97. What is the ratio of the Educated males (% of male labor force) in New Zealand in 2004 to that in 2007?
Offer a very short reply. 1.29. What is the ratio of the Educated males (% of male labor force) in Australia in 2004 to that in 2008?
Make the answer very short. 0.96. What is the ratio of the Educated males (% of male labor force) of Bulgaria in 2004 to that in 2008?
Ensure brevity in your answer.  0.93. What is the ratio of the Educated males (% of male labor force) in Ireland in 2004 to that in 2008?
Offer a very short reply. 0.96. What is the ratio of the Educated males (% of male labor force) in New Zealand in 2004 to that in 2008?
Offer a terse response. 1.3. What is the ratio of the Educated males (% of male labor force) in Australia in 2005 to that in 2006?
Give a very brief answer. 0.97. What is the ratio of the Educated males (% of male labor force) in Bulgaria in 2005 to that in 2006?
Provide a short and direct response. 0.95. What is the ratio of the Educated males (% of male labor force) in Ireland in 2005 to that in 2006?
Make the answer very short. 1. What is the ratio of the Educated males (% of male labor force) in New Zealand in 2005 to that in 2006?
Provide a short and direct response. 1.25. What is the ratio of the Educated males (% of male labor force) of Australia in 2005 to that in 2007?
Make the answer very short. 0.92. What is the ratio of the Educated males (% of male labor force) of Bulgaria in 2005 to that in 2007?
Your answer should be very brief. 0.94. What is the ratio of the Educated males (% of male labor force) in Ireland in 2005 to that in 2007?
Your answer should be very brief. 0.99. What is the ratio of the Educated males (% of male labor force) in New Zealand in 2005 to that in 2007?
Your answer should be compact. 1.29. What is the ratio of the Educated males (% of male labor force) of Australia in 2005 to that in 2008?
Keep it short and to the point. 0.93. What is the ratio of the Educated males (% of male labor force) in Bulgaria in 2005 to that in 2008?
Provide a short and direct response. 0.95. What is the ratio of the Educated males (% of male labor force) of Ireland in 2005 to that in 2008?
Make the answer very short. 0.98. What is the ratio of the Educated males (% of male labor force) in New Zealand in 2005 to that in 2008?
Your response must be concise. 1.3. What is the ratio of the Educated males (% of male labor force) in Australia in 2006 to that in 2007?
Make the answer very short. 0.95. What is the ratio of the Educated males (% of male labor force) of Bulgaria in 2006 to that in 2007?
Your response must be concise. 0.98. What is the ratio of the Educated males (% of male labor force) in Ireland in 2006 to that in 2007?
Ensure brevity in your answer.  0.99. What is the ratio of the Educated males (% of male labor force) of New Zealand in 2006 to that in 2007?
Keep it short and to the point. 1.03. What is the ratio of the Educated males (% of male labor force) in Australia in 2006 to that in 2008?
Your response must be concise. 0.95. What is the ratio of the Educated males (% of male labor force) of Ireland in 2006 to that in 2008?
Your response must be concise. 0.98. What is the ratio of the Educated males (% of male labor force) of New Zealand in 2006 to that in 2008?
Keep it short and to the point. 1.04. What is the ratio of the Educated males (% of male labor force) of Australia in 2007 to that in 2008?
Make the answer very short. 1. What is the ratio of the Educated males (% of male labor force) in Bulgaria in 2007 to that in 2008?
Ensure brevity in your answer.  1.01. What is the ratio of the Educated males (% of male labor force) in Ireland in 2007 to that in 2008?
Provide a succinct answer. 0.99. What is the ratio of the Educated males (% of male labor force) of New Zealand in 2007 to that in 2008?
Provide a short and direct response. 1.01. What is the difference between the highest and the lowest Educated males (% of male labor force) in Australia?
Ensure brevity in your answer.  7.3. What is the difference between the highest and the lowest Educated males (% of male labor force) in Bulgaria?
Provide a succinct answer. 6.9. What is the difference between the highest and the lowest Educated males (% of male labor force) of Ireland?
Provide a short and direct response. 1.4. What is the difference between the highest and the lowest Educated males (% of male labor force) in New Zealand?
Your answer should be compact. 13.3. 